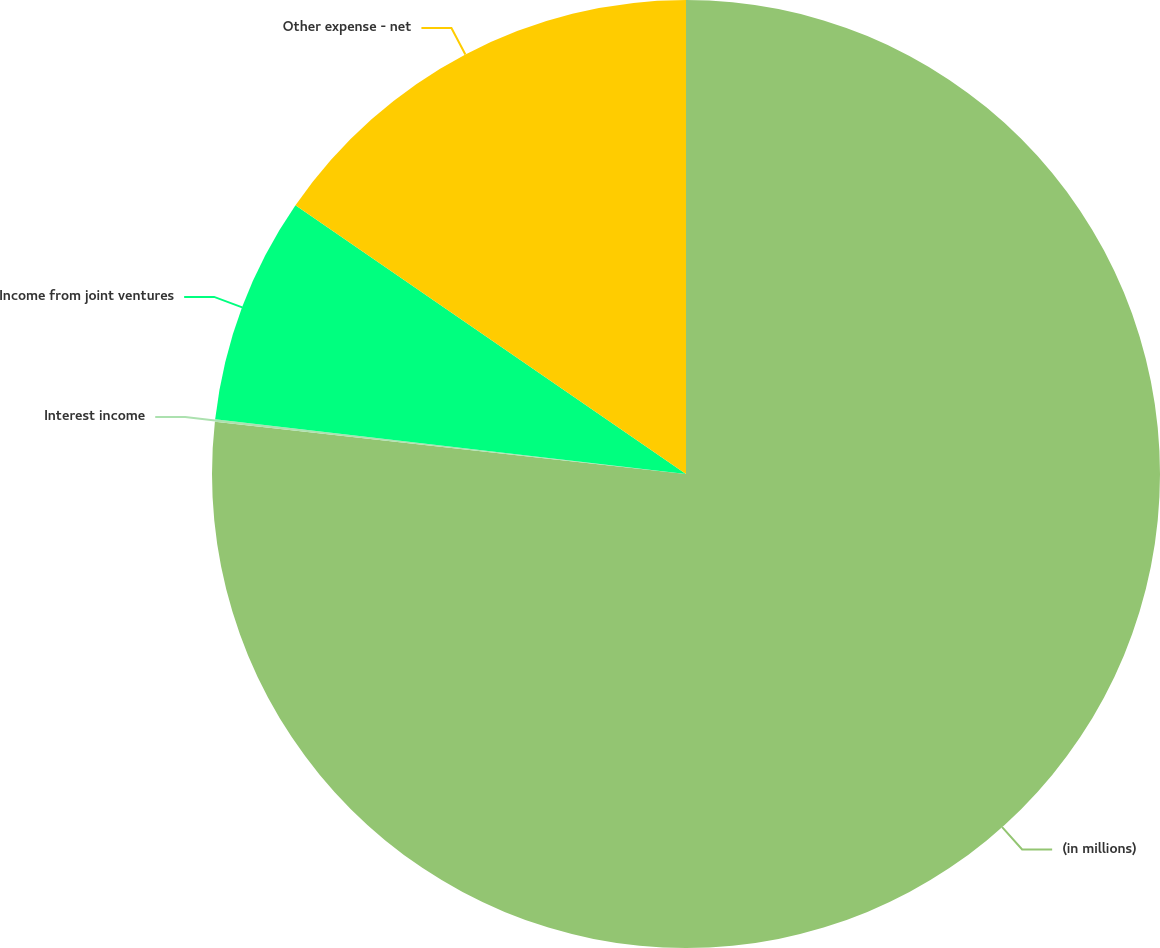Convert chart to OTSL. <chart><loc_0><loc_0><loc_500><loc_500><pie_chart><fcel>(in millions)<fcel>Interest income<fcel>Income from joint ventures<fcel>Other expense - net<nl><fcel>76.76%<fcel>0.08%<fcel>7.75%<fcel>15.41%<nl></chart> 